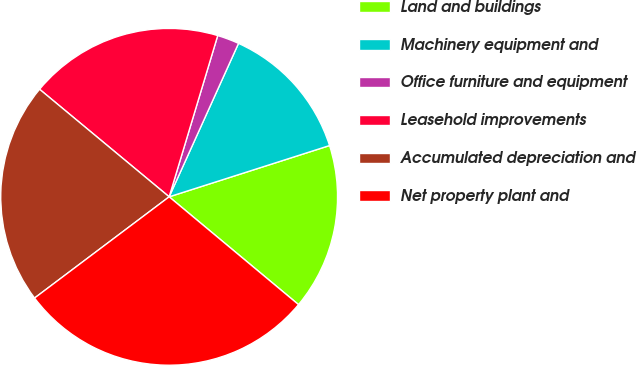Convert chart to OTSL. <chart><loc_0><loc_0><loc_500><loc_500><pie_chart><fcel>Land and buildings<fcel>Machinery equipment and<fcel>Office furniture and equipment<fcel>Leasehold improvements<fcel>Accumulated depreciation and<fcel>Net property plant and<nl><fcel>15.98%<fcel>13.32%<fcel>2.1%<fcel>18.63%<fcel>21.29%<fcel>28.68%<nl></chart> 